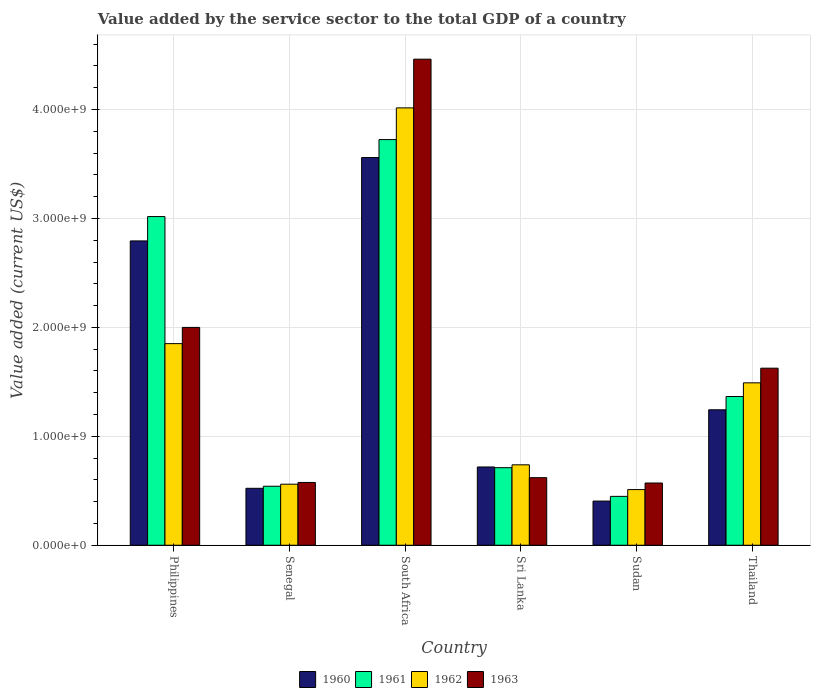Are the number of bars on each tick of the X-axis equal?
Offer a terse response. Yes. What is the label of the 3rd group of bars from the left?
Ensure brevity in your answer.  South Africa. What is the value added by the service sector to the total GDP in 1960 in Thailand?
Provide a succinct answer. 1.24e+09. Across all countries, what is the maximum value added by the service sector to the total GDP in 1962?
Provide a short and direct response. 4.01e+09. Across all countries, what is the minimum value added by the service sector to the total GDP in 1963?
Provide a short and direct response. 5.71e+08. In which country was the value added by the service sector to the total GDP in 1960 maximum?
Ensure brevity in your answer.  South Africa. In which country was the value added by the service sector to the total GDP in 1961 minimum?
Make the answer very short. Sudan. What is the total value added by the service sector to the total GDP in 1960 in the graph?
Ensure brevity in your answer.  9.24e+09. What is the difference between the value added by the service sector to the total GDP in 1960 in Senegal and that in Sri Lanka?
Your answer should be very brief. -1.96e+08. What is the difference between the value added by the service sector to the total GDP in 1961 in Sri Lanka and the value added by the service sector to the total GDP in 1963 in Thailand?
Your answer should be compact. -9.13e+08. What is the average value added by the service sector to the total GDP in 1961 per country?
Your answer should be compact. 1.63e+09. What is the difference between the value added by the service sector to the total GDP of/in 1963 and value added by the service sector to the total GDP of/in 1961 in Sri Lanka?
Offer a very short reply. -9.18e+07. In how many countries, is the value added by the service sector to the total GDP in 1961 greater than 4200000000 US$?
Give a very brief answer. 0. What is the ratio of the value added by the service sector to the total GDP in 1961 in Philippines to that in Sudan?
Your answer should be compact. 6.73. Is the value added by the service sector to the total GDP in 1963 in Senegal less than that in South Africa?
Ensure brevity in your answer.  Yes. What is the difference between the highest and the second highest value added by the service sector to the total GDP in 1961?
Provide a succinct answer. -7.07e+08. What is the difference between the highest and the lowest value added by the service sector to the total GDP in 1960?
Offer a very short reply. 3.15e+09. What does the 1st bar from the left in South Africa represents?
Ensure brevity in your answer.  1960. Is it the case that in every country, the sum of the value added by the service sector to the total GDP in 1961 and value added by the service sector to the total GDP in 1962 is greater than the value added by the service sector to the total GDP in 1960?
Provide a short and direct response. Yes. How many bars are there?
Offer a terse response. 24. How many countries are there in the graph?
Offer a terse response. 6. Are the values on the major ticks of Y-axis written in scientific E-notation?
Offer a terse response. Yes. Does the graph contain grids?
Make the answer very short. Yes. Where does the legend appear in the graph?
Offer a very short reply. Bottom center. What is the title of the graph?
Keep it short and to the point. Value added by the service sector to the total GDP of a country. Does "1977" appear as one of the legend labels in the graph?
Your answer should be very brief. No. What is the label or title of the Y-axis?
Provide a short and direct response. Value added (current US$). What is the Value added (current US$) of 1960 in Philippines?
Provide a succinct answer. 2.79e+09. What is the Value added (current US$) of 1961 in Philippines?
Provide a succinct answer. 3.02e+09. What is the Value added (current US$) in 1962 in Philippines?
Provide a succinct answer. 1.85e+09. What is the Value added (current US$) of 1963 in Philippines?
Provide a short and direct response. 2.00e+09. What is the Value added (current US$) of 1960 in Senegal?
Provide a succinct answer. 5.23e+08. What is the Value added (current US$) in 1961 in Senegal?
Your answer should be compact. 5.42e+08. What is the Value added (current US$) in 1962 in Senegal?
Offer a terse response. 5.60e+08. What is the Value added (current US$) of 1963 in Senegal?
Provide a succinct answer. 5.76e+08. What is the Value added (current US$) in 1960 in South Africa?
Offer a very short reply. 3.56e+09. What is the Value added (current US$) in 1961 in South Africa?
Your response must be concise. 3.72e+09. What is the Value added (current US$) in 1962 in South Africa?
Give a very brief answer. 4.01e+09. What is the Value added (current US$) of 1963 in South Africa?
Provide a succinct answer. 4.46e+09. What is the Value added (current US$) in 1960 in Sri Lanka?
Ensure brevity in your answer.  7.18e+08. What is the Value added (current US$) in 1961 in Sri Lanka?
Give a very brief answer. 7.12e+08. What is the Value added (current US$) in 1962 in Sri Lanka?
Ensure brevity in your answer.  7.38e+08. What is the Value added (current US$) of 1963 in Sri Lanka?
Provide a succinct answer. 6.20e+08. What is the Value added (current US$) of 1960 in Sudan?
Provide a short and direct response. 4.06e+08. What is the Value added (current US$) of 1961 in Sudan?
Make the answer very short. 4.49e+08. What is the Value added (current US$) of 1962 in Sudan?
Your answer should be compact. 5.11e+08. What is the Value added (current US$) in 1963 in Sudan?
Offer a terse response. 5.71e+08. What is the Value added (current US$) in 1960 in Thailand?
Your answer should be compact. 1.24e+09. What is the Value added (current US$) of 1961 in Thailand?
Offer a very short reply. 1.37e+09. What is the Value added (current US$) in 1962 in Thailand?
Keep it short and to the point. 1.49e+09. What is the Value added (current US$) in 1963 in Thailand?
Provide a short and direct response. 1.63e+09. Across all countries, what is the maximum Value added (current US$) of 1960?
Provide a succinct answer. 3.56e+09. Across all countries, what is the maximum Value added (current US$) of 1961?
Offer a terse response. 3.72e+09. Across all countries, what is the maximum Value added (current US$) of 1962?
Provide a short and direct response. 4.01e+09. Across all countries, what is the maximum Value added (current US$) of 1963?
Ensure brevity in your answer.  4.46e+09. Across all countries, what is the minimum Value added (current US$) of 1960?
Your response must be concise. 4.06e+08. Across all countries, what is the minimum Value added (current US$) of 1961?
Make the answer very short. 4.49e+08. Across all countries, what is the minimum Value added (current US$) in 1962?
Keep it short and to the point. 5.11e+08. Across all countries, what is the minimum Value added (current US$) in 1963?
Provide a succinct answer. 5.71e+08. What is the total Value added (current US$) in 1960 in the graph?
Your response must be concise. 9.24e+09. What is the total Value added (current US$) of 1961 in the graph?
Offer a very short reply. 9.81e+09. What is the total Value added (current US$) in 1962 in the graph?
Provide a succinct answer. 9.17e+09. What is the total Value added (current US$) in 1963 in the graph?
Your answer should be very brief. 9.85e+09. What is the difference between the Value added (current US$) in 1960 in Philippines and that in Senegal?
Give a very brief answer. 2.27e+09. What is the difference between the Value added (current US$) in 1961 in Philippines and that in Senegal?
Give a very brief answer. 2.48e+09. What is the difference between the Value added (current US$) of 1962 in Philippines and that in Senegal?
Your answer should be compact. 1.29e+09. What is the difference between the Value added (current US$) in 1963 in Philippines and that in Senegal?
Ensure brevity in your answer.  1.42e+09. What is the difference between the Value added (current US$) of 1960 in Philippines and that in South Africa?
Give a very brief answer. -7.66e+08. What is the difference between the Value added (current US$) of 1961 in Philippines and that in South Africa?
Give a very brief answer. -7.07e+08. What is the difference between the Value added (current US$) of 1962 in Philippines and that in South Africa?
Give a very brief answer. -2.16e+09. What is the difference between the Value added (current US$) of 1963 in Philippines and that in South Africa?
Your answer should be compact. -2.46e+09. What is the difference between the Value added (current US$) in 1960 in Philippines and that in Sri Lanka?
Your answer should be very brief. 2.08e+09. What is the difference between the Value added (current US$) of 1961 in Philippines and that in Sri Lanka?
Give a very brief answer. 2.31e+09. What is the difference between the Value added (current US$) of 1962 in Philippines and that in Sri Lanka?
Provide a succinct answer. 1.11e+09. What is the difference between the Value added (current US$) in 1963 in Philippines and that in Sri Lanka?
Keep it short and to the point. 1.38e+09. What is the difference between the Value added (current US$) of 1960 in Philippines and that in Sudan?
Keep it short and to the point. 2.39e+09. What is the difference between the Value added (current US$) in 1961 in Philippines and that in Sudan?
Your answer should be compact. 2.57e+09. What is the difference between the Value added (current US$) of 1962 in Philippines and that in Sudan?
Offer a terse response. 1.34e+09. What is the difference between the Value added (current US$) in 1963 in Philippines and that in Sudan?
Offer a very short reply. 1.43e+09. What is the difference between the Value added (current US$) in 1960 in Philippines and that in Thailand?
Make the answer very short. 1.55e+09. What is the difference between the Value added (current US$) of 1961 in Philippines and that in Thailand?
Provide a succinct answer. 1.65e+09. What is the difference between the Value added (current US$) of 1962 in Philippines and that in Thailand?
Your response must be concise. 3.60e+08. What is the difference between the Value added (current US$) of 1963 in Philippines and that in Thailand?
Your answer should be compact. 3.74e+08. What is the difference between the Value added (current US$) in 1960 in Senegal and that in South Africa?
Make the answer very short. -3.04e+09. What is the difference between the Value added (current US$) in 1961 in Senegal and that in South Africa?
Your response must be concise. -3.18e+09. What is the difference between the Value added (current US$) in 1962 in Senegal and that in South Africa?
Keep it short and to the point. -3.45e+09. What is the difference between the Value added (current US$) of 1963 in Senegal and that in South Africa?
Provide a short and direct response. -3.89e+09. What is the difference between the Value added (current US$) in 1960 in Senegal and that in Sri Lanka?
Provide a short and direct response. -1.96e+08. What is the difference between the Value added (current US$) in 1961 in Senegal and that in Sri Lanka?
Offer a terse response. -1.70e+08. What is the difference between the Value added (current US$) in 1962 in Senegal and that in Sri Lanka?
Offer a very short reply. -1.78e+08. What is the difference between the Value added (current US$) in 1963 in Senegal and that in Sri Lanka?
Provide a succinct answer. -4.38e+07. What is the difference between the Value added (current US$) of 1960 in Senegal and that in Sudan?
Offer a terse response. 1.17e+08. What is the difference between the Value added (current US$) of 1961 in Senegal and that in Sudan?
Provide a succinct answer. 9.30e+07. What is the difference between the Value added (current US$) in 1962 in Senegal and that in Sudan?
Give a very brief answer. 4.95e+07. What is the difference between the Value added (current US$) of 1963 in Senegal and that in Sudan?
Offer a terse response. 5.17e+06. What is the difference between the Value added (current US$) in 1960 in Senegal and that in Thailand?
Keep it short and to the point. -7.21e+08. What is the difference between the Value added (current US$) in 1961 in Senegal and that in Thailand?
Provide a short and direct response. -8.24e+08. What is the difference between the Value added (current US$) of 1962 in Senegal and that in Thailand?
Offer a terse response. -9.30e+08. What is the difference between the Value added (current US$) of 1963 in Senegal and that in Thailand?
Make the answer very short. -1.05e+09. What is the difference between the Value added (current US$) of 1960 in South Africa and that in Sri Lanka?
Provide a succinct answer. 2.84e+09. What is the difference between the Value added (current US$) in 1961 in South Africa and that in Sri Lanka?
Provide a short and direct response. 3.01e+09. What is the difference between the Value added (current US$) in 1962 in South Africa and that in Sri Lanka?
Offer a terse response. 3.28e+09. What is the difference between the Value added (current US$) of 1963 in South Africa and that in Sri Lanka?
Your answer should be very brief. 3.84e+09. What is the difference between the Value added (current US$) in 1960 in South Africa and that in Sudan?
Make the answer very short. 3.15e+09. What is the difference between the Value added (current US$) of 1961 in South Africa and that in Sudan?
Your answer should be very brief. 3.28e+09. What is the difference between the Value added (current US$) in 1962 in South Africa and that in Sudan?
Provide a succinct answer. 3.50e+09. What is the difference between the Value added (current US$) of 1963 in South Africa and that in Sudan?
Your response must be concise. 3.89e+09. What is the difference between the Value added (current US$) in 1960 in South Africa and that in Thailand?
Give a very brief answer. 2.32e+09. What is the difference between the Value added (current US$) in 1961 in South Africa and that in Thailand?
Give a very brief answer. 2.36e+09. What is the difference between the Value added (current US$) of 1962 in South Africa and that in Thailand?
Your answer should be very brief. 2.52e+09. What is the difference between the Value added (current US$) of 1963 in South Africa and that in Thailand?
Give a very brief answer. 2.84e+09. What is the difference between the Value added (current US$) in 1960 in Sri Lanka and that in Sudan?
Provide a short and direct response. 3.13e+08. What is the difference between the Value added (current US$) of 1961 in Sri Lanka and that in Sudan?
Make the answer very short. 2.63e+08. What is the difference between the Value added (current US$) in 1962 in Sri Lanka and that in Sudan?
Your answer should be compact. 2.27e+08. What is the difference between the Value added (current US$) in 1963 in Sri Lanka and that in Sudan?
Provide a succinct answer. 4.89e+07. What is the difference between the Value added (current US$) of 1960 in Sri Lanka and that in Thailand?
Keep it short and to the point. -5.25e+08. What is the difference between the Value added (current US$) in 1961 in Sri Lanka and that in Thailand?
Your answer should be compact. -6.53e+08. What is the difference between the Value added (current US$) in 1962 in Sri Lanka and that in Thailand?
Make the answer very short. -7.53e+08. What is the difference between the Value added (current US$) of 1963 in Sri Lanka and that in Thailand?
Offer a very short reply. -1.01e+09. What is the difference between the Value added (current US$) in 1960 in Sudan and that in Thailand?
Offer a terse response. -8.38e+08. What is the difference between the Value added (current US$) of 1961 in Sudan and that in Thailand?
Make the answer very short. -9.17e+08. What is the difference between the Value added (current US$) of 1962 in Sudan and that in Thailand?
Your response must be concise. -9.80e+08. What is the difference between the Value added (current US$) in 1963 in Sudan and that in Thailand?
Make the answer very short. -1.05e+09. What is the difference between the Value added (current US$) in 1960 in Philippines and the Value added (current US$) in 1961 in Senegal?
Offer a very short reply. 2.25e+09. What is the difference between the Value added (current US$) of 1960 in Philippines and the Value added (current US$) of 1962 in Senegal?
Make the answer very short. 2.23e+09. What is the difference between the Value added (current US$) in 1960 in Philippines and the Value added (current US$) in 1963 in Senegal?
Offer a terse response. 2.22e+09. What is the difference between the Value added (current US$) in 1961 in Philippines and the Value added (current US$) in 1962 in Senegal?
Ensure brevity in your answer.  2.46e+09. What is the difference between the Value added (current US$) in 1961 in Philippines and the Value added (current US$) in 1963 in Senegal?
Your response must be concise. 2.44e+09. What is the difference between the Value added (current US$) of 1962 in Philippines and the Value added (current US$) of 1963 in Senegal?
Provide a succinct answer. 1.27e+09. What is the difference between the Value added (current US$) in 1960 in Philippines and the Value added (current US$) in 1961 in South Africa?
Offer a terse response. -9.30e+08. What is the difference between the Value added (current US$) of 1960 in Philippines and the Value added (current US$) of 1962 in South Africa?
Give a very brief answer. -1.22e+09. What is the difference between the Value added (current US$) in 1960 in Philippines and the Value added (current US$) in 1963 in South Africa?
Your answer should be compact. -1.67e+09. What is the difference between the Value added (current US$) in 1961 in Philippines and the Value added (current US$) in 1962 in South Africa?
Your response must be concise. -9.98e+08. What is the difference between the Value added (current US$) of 1961 in Philippines and the Value added (current US$) of 1963 in South Africa?
Offer a very short reply. -1.44e+09. What is the difference between the Value added (current US$) of 1962 in Philippines and the Value added (current US$) of 1963 in South Africa?
Ensure brevity in your answer.  -2.61e+09. What is the difference between the Value added (current US$) in 1960 in Philippines and the Value added (current US$) in 1961 in Sri Lanka?
Keep it short and to the point. 2.08e+09. What is the difference between the Value added (current US$) in 1960 in Philippines and the Value added (current US$) in 1962 in Sri Lanka?
Your answer should be very brief. 2.06e+09. What is the difference between the Value added (current US$) in 1960 in Philippines and the Value added (current US$) in 1963 in Sri Lanka?
Your answer should be very brief. 2.17e+09. What is the difference between the Value added (current US$) of 1961 in Philippines and the Value added (current US$) of 1962 in Sri Lanka?
Offer a very short reply. 2.28e+09. What is the difference between the Value added (current US$) in 1961 in Philippines and the Value added (current US$) in 1963 in Sri Lanka?
Offer a very short reply. 2.40e+09. What is the difference between the Value added (current US$) of 1962 in Philippines and the Value added (current US$) of 1963 in Sri Lanka?
Your answer should be very brief. 1.23e+09. What is the difference between the Value added (current US$) of 1960 in Philippines and the Value added (current US$) of 1961 in Sudan?
Your answer should be compact. 2.35e+09. What is the difference between the Value added (current US$) of 1960 in Philippines and the Value added (current US$) of 1962 in Sudan?
Your answer should be very brief. 2.28e+09. What is the difference between the Value added (current US$) in 1960 in Philippines and the Value added (current US$) in 1963 in Sudan?
Your answer should be compact. 2.22e+09. What is the difference between the Value added (current US$) of 1961 in Philippines and the Value added (current US$) of 1962 in Sudan?
Your answer should be compact. 2.51e+09. What is the difference between the Value added (current US$) in 1961 in Philippines and the Value added (current US$) in 1963 in Sudan?
Provide a short and direct response. 2.45e+09. What is the difference between the Value added (current US$) in 1962 in Philippines and the Value added (current US$) in 1963 in Sudan?
Offer a terse response. 1.28e+09. What is the difference between the Value added (current US$) of 1960 in Philippines and the Value added (current US$) of 1961 in Thailand?
Give a very brief answer. 1.43e+09. What is the difference between the Value added (current US$) of 1960 in Philippines and the Value added (current US$) of 1962 in Thailand?
Provide a succinct answer. 1.30e+09. What is the difference between the Value added (current US$) of 1960 in Philippines and the Value added (current US$) of 1963 in Thailand?
Make the answer very short. 1.17e+09. What is the difference between the Value added (current US$) in 1961 in Philippines and the Value added (current US$) in 1962 in Thailand?
Offer a terse response. 1.53e+09. What is the difference between the Value added (current US$) of 1961 in Philippines and the Value added (current US$) of 1963 in Thailand?
Give a very brief answer. 1.39e+09. What is the difference between the Value added (current US$) of 1962 in Philippines and the Value added (current US$) of 1963 in Thailand?
Ensure brevity in your answer.  2.25e+08. What is the difference between the Value added (current US$) of 1960 in Senegal and the Value added (current US$) of 1961 in South Africa?
Offer a terse response. -3.20e+09. What is the difference between the Value added (current US$) in 1960 in Senegal and the Value added (current US$) in 1962 in South Africa?
Provide a succinct answer. -3.49e+09. What is the difference between the Value added (current US$) of 1960 in Senegal and the Value added (current US$) of 1963 in South Africa?
Your answer should be very brief. -3.94e+09. What is the difference between the Value added (current US$) of 1961 in Senegal and the Value added (current US$) of 1962 in South Africa?
Provide a short and direct response. -3.47e+09. What is the difference between the Value added (current US$) in 1961 in Senegal and the Value added (current US$) in 1963 in South Africa?
Ensure brevity in your answer.  -3.92e+09. What is the difference between the Value added (current US$) in 1962 in Senegal and the Value added (current US$) in 1963 in South Africa?
Your answer should be compact. -3.90e+09. What is the difference between the Value added (current US$) of 1960 in Senegal and the Value added (current US$) of 1961 in Sri Lanka?
Keep it short and to the point. -1.89e+08. What is the difference between the Value added (current US$) of 1960 in Senegal and the Value added (current US$) of 1962 in Sri Lanka?
Ensure brevity in your answer.  -2.16e+08. What is the difference between the Value added (current US$) of 1960 in Senegal and the Value added (current US$) of 1963 in Sri Lanka?
Offer a terse response. -9.75e+07. What is the difference between the Value added (current US$) of 1961 in Senegal and the Value added (current US$) of 1962 in Sri Lanka?
Offer a very short reply. -1.97e+08. What is the difference between the Value added (current US$) in 1961 in Senegal and the Value added (current US$) in 1963 in Sri Lanka?
Make the answer very short. -7.85e+07. What is the difference between the Value added (current US$) in 1962 in Senegal and the Value added (current US$) in 1963 in Sri Lanka?
Your response must be concise. -5.98e+07. What is the difference between the Value added (current US$) in 1960 in Senegal and the Value added (current US$) in 1961 in Sudan?
Your answer should be very brief. 7.40e+07. What is the difference between the Value added (current US$) in 1960 in Senegal and the Value added (current US$) in 1962 in Sudan?
Your response must be concise. 1.17e+07. What is the difference between the Value added (current US$) of 1960 in Senegal and the Value added (current US$) of 1963 in Sudan?
Ensure brevity in your answer.  -4.86e+07. What is the difference between the Value added (current US$) of 1961 in Senegal and the Value added (current US$) of 1962 in Sudan?
Ensure brevity in your answer.  3.07e+07. What is the difference between the Value added (current US$) in 1961 in Senegal and the Value added (current US$) in 1963 in Sudan?
Your answer should be compact. -2.96e+07. What is the difference between the Value added (current US$) of 1962 in Senegal and the Value added (current US$) of 1963 in Sudan?
Offer a terse response. -1.08e+07. What is the difference between the Value added (current US$) in 1960 in Senegal and the Value added (current US$) in 1961 in Thailand?
Provide a short and direct response. -8.43e+08. What is the difference between the Value added (current US$) of 1960 in Senegal and the Value added (current US$) of 1962 in Thailand?
Provide a short and direct response. -9.68e+08. What is the difference between the Value added (current US$) in 1960 in Senegal and the Value added (current US$) in 1963 in Thailand?
Offer a very short reply. -1.10e+09. What is the difference between the Value added (current US$) in 1961 in Senegal and the Value added (current US$) in 1962 in Thailand?
Make the answer very short. -9.49e+08. What is the difference between the Value added (current US$) of 1961 in Senegal and the Value added (current US$) of 1963 in Thailand?
Your response must be concise. -1.08e+09. What is the difference between the Value added (current US$) in 1962 in Senegal and the Value added (current US$) in 1963 in Thailand?
Keep it short and to the point. -1.06e+09. What is the difference between the Value added (current US$) in 1960 in South Africa and the Value added (current US$) in 1961 in Sri Lanka?
Your response must be concise. 2.85e+09. What is the difference between the Value added (current US$) of 1960 in South Africa and the Value added (current US$) of 1962 in Sri Lanka?
Provide a short and direct response. 2.82e+09. What is the difference between the Value added (current US$) of 1960 in South Africa and the Value added (current US$) of 1963 in Sri Lanka?
Make the answer very short. 2.94e+09. What is the difference between the Value added (current US$) in 1961 in South Africa and the Value added (current US$) in 1962 in Sri Lanka?
Your answer should be very brief. 2.99e+09. What is the difference between the Value added (current US$) in 1961 in South Africa and the Value added (current US$) in 1963 in Sri Lanka?
Your response must be concise. 3.10e+09. What is the difference between the Value added (current US$) of 1962 in South Africa and the Value added (current US$) of 1963 in Sri Lanka?
Ensure brevity in your answer.  3.39e+09. What is the difference between the Value added (current US$) in 1960 in South Africa and the Value added (current US$) in 1961 in Sudan?
Provide a short and direct response. 3.11e+09. What is the difference between the Value added (current US$) of 1960 in South Africa and the Value added (current US$) of 1962 in Sudan?
Keep it short and to the point. 3.05e+09. What is the difference between the Value added (current US$) of 1960 in South Africa and the Value added (current US$) of 1963 in Sudan?
Your answer should be very brief. 2.99e+09. What is the difference between the Value added (current US$) of 1961 in South Africa and the Value added (current US$) of 1962 in Sudan?
Make the answer very short. 3.21e+09. What is the difference between the Value added (current US$) of 1961 in South Africa and the Value added (current US$) of 1963 in Sudan?
Your answer should be very brief. 3.15e+09. What is the difference between the Value added (current US$) of 1962 in South Africa and the Value added (current US$) of 1963 in Sudan?
Your answer should be compact. 3.44e+09. What is the difference between the Value added (current US$) in 1960 in South Africa and the Value added (current US$) in 1961 in Thailand?
Provide a short and direct response. 2.19e+09. What is the difference between the Value added (current US$) in 1960 in South Africa and the Value added (current US$) in 1962 in Thailand?
Provide a short and direct response. 2.07e+09. What is the difference between the Value added (current US$) of 1960 in South Africa and the Value added (current US$) of 1963 in Thailand?
Provide a short and direct response. 1.93e+09. What is the difference between the Value added (current US$) in 1961 in South Africa and the Value added (current US$) in 1962 in Thailand?
Your response must be concise. 2.23e+09. What is the difference between the Value added (current US$) in 1961 in South Africa and the Value added (current US$) in 1963 in Thailand?
Offer a very short reply. 2.10e+09. What is the difference between the Value added (current US$) in 1962 in South Africa and the Value added (current US$) in 1963 in Thailand?
Ensure brevity in your answer.  2.39e+09. What is the difference between the Value added (current US$) of 1960 in Sri Lanka and the Value added (current US$) of 1961 in Sudan?
Ensure brevity in your answer.  2.70e+08. What is the difference between the Value added (current US$) in 1960 in Sri Lanka and the Value added (current US$) in 1962 in Sudan?
Make the answer very short. 2.08e+08. What is the difference between the Value added (current US$) of 1960 in Sri Lanka and the Value added (current US$) of 1963 in Sudan?
Make the answer very short. 1.47e+08. What is the difference between the Value added (current US$) in 1961 in Sri Lanka and the Value added (current US$) in 1962 in Sudan?
Provide a succinct answer. 2.01e+08. What is the difference between the Value added (current US$) of 1961 in Sri Lanka and the Value added (current US$) of 1963 in Sudan?
Your answer should be compact. 1.41e+08. What is the difference between the Value added (current US$) of 1962 in Sri Lanka and the Value added (current US$) of 1963 in Sudan?
Provide a succinct answer. 1.67e+08. What is the difference between the Value added (current US$) of 1960 in Sri Lanka and the Value added (current US$) of 1961 in Thailand?
Give a very brief answer. -6.47e+08. What is the difference between the Value added (current US$) of 1960 in Sri Lanka and the Value added (current US$) of 1962 in Thailand?
Ensure brevity in your answer.  -7.72e+08. What is the difference between the Value added (current US$) in 1960 in Sri Lanka and the Value added (current US$) in 1963 in Thailand?
Make the answer very short. -9.07e+08. What is the difference between the Value added (current US$) in 1961 in Sri Lanka and the Value added (current US$) in 1962 in Thailand?
Ensure brevity in your answer.  -7.79e+08. What is the difference between the Value added (current US$) of 1961 in Sri Lanka and the Value added (current US$) of 1963 in Thailand?
Your response must be concise. -9.13e+08. What is the difference between the Value added (current US$) in 1962 in Sri Lanka and the Value added (current US$) in 1963 in Thailand?
Offer a very short reply. -8.87e+08. What is the difference between the Value added (current US$) of 1960 in Sudan and the Value added (current US$) of 1961 in Thailand?
Make the answer very short. -9.60e+08. What is the difference between the Value added (current US$) of 1960 in Sudan and the Value added (current US$) of 1962 in Thailand?
Offer a very short reply. -1.09e+09. What is the difference between the Value added (current US$) in 1960 in Sudan and the Value added (current US$) in 1963 in Thailand?
Offer a very short reply. -1.22e+09. What is the difference between the Value added (current US$) in 1961 in Sudan and the Value added (current US$) in 1962 in Thailand?
Make the answer very short. -1.04e+09. What is the difference between the Value added (current US$) of 1961 in Sudan and the Value added (current US$) of 1963 in Thailand?
Provide a short and direct response. -1.18e+09. What is the difference between the Value added (current US$) in 1962 in Sudan and the Value added (current US$) in 1963 in Thailand?
Your answer should be very brief. -1.11e+09. What is the average Value added (current US$) of 1960 per country?
Ensure brevity in your answer.  1.54e+09. What is the average Value added (current US$) in 1961 per country?
Your response must be concise. 1.63e+09. What is the average Value added (current US$) of 1962 per country?
Provide a succinct answer. 1.53e+09. What is the average Value added (current US$) in 1963 per country?
Offer a terse response. 1.64e+09. What is the difference between the Value added (current US$) of 1960 and Value added (current US$) of 1961 in Philippines?
Your answer should be very brief. -2.24e+08. What is the difference between the Value added (current US$) in 1960 and Value added (current US$) in 1962 in Philippines?
Keep it short and to the point. 9.43e+08. What is the difference between the Value added (current US$) in 1960 and Value added (current US$) in 1963 in Philippines?
Provide a succinct answer. 7.94e+08. What is the difference between the Value added (current US$) of 1961 and Value added (current US$) of 1962 in Philippines?
Your response must be concise. 1.17e+09. What is the difference between the Value added (current US$) in 1961 and Value added (current US$) in 1963 in Philippines?
Ensure brevity in your answer.  1.02e+09. What is the difference between the Value added (current US$) in 1962 and Value added (current US$) in 1963 in Philippines?
Make the answer very short. -1.49e+08. What is the difference between the Value added (current US$) of 1960 and Value added (current US$) of 1961 in Senegal?
Provide a succinct answer. -1.90e+07. What is the difference between the Value added (current US$) of 1960 and Value added (current US$) of 1962 in Senegal?
Provide a succinct answer. -3.77e+07. What is the difference between the Value added (current US$) in 1960 and Value added (current US$) in 1963 in Senegal?
Your answer should be compact. -5.38e+07. What is the difference between the Value added (current US$) in 1961 and Value added (current US$) in 1962 in Senegal?
Offer a very short reply. -1.87e+07. What is the difference between the Value added (current US$) in 1961 and Value added (current US$) in 1963 in Senegal?
Offer a very short reply. -3.48e+07. What is the difference between the Value added (current US$) of 1962 and Value added (current US$) of 1963 in Senegal?
Provide a succinct answer. -1.60e+07. What is the difference between the Value added (current US$) of 1960 and Value added (current US$) of 1961 in South Africa?
Give a very brief answer. -1.65e+08. What is the difference between the Value added (current US$) in 1960 and Value added (current US$) in 1962 in South Africa?
Your answer should be compact. -4.56e+08. What is the difference between the Value added (current US$) in 1960 and Value added (current US$) in 1963 in South Africa?
Offer a very short reply. -9.03e+08. What is the difference between the Value added (current US$) of 1961 and Value added (current US$) of 1962 in South Africa?
Your response must be concise. -2.91e+08. What is the difference between the Value added (current US$) of 1961 and Value added (current US$) of 1963 in South Africa?
Give a very brief answer. -7.38e+08. What is the difference between the Value added (current US$) of 1962 and Value added (current US$) of 1963 in South Africa?
Offer a terse response. -4.47e+08. What is the difference between the Value added (current US$) of 1960 and Value added (current US$) of 1961 in Sri Lanka?
Keep it short and to the point. 6.51e+06. What is the difference between the Value added (current US$) of 1960 and Value added (current US$) of 1962 in Sri Lanka?
Give a very brief answer. -1.98e+07. What is the difference between the Value added (current US$) of 1960 and Value added (current US$) of 1963 in Sri Lanka?
Your answer should be very brief. 9.83e+07. What is the difference between the Value added (current US$) in 1961 and Value added (current US$) in 1962 in Sri Lanka?
Provide a succinct answer. -2.63e+07. What is the difference between the Value added (current US$) in 1961 and Value added (current US$) in 1963 in Sri Lanka?
Provide a short and direct response. 9.18e+07. What is the difference between the Value added (current US$) in 1962 and Value added (current US$) in 1963 in Sri Lanka?
Offer a terse response. 1.18e+08. What is the difference between the Value added (current US$) of 1960 and Value added (current US$) of 1961 in Sudan?
Offer a very short reply. -4.31e+07. What is the difference between the Value added (current US$) in 1960 and Value added (current US$) in 1962 in Sudan?
Give a very brief answer. -1.05e+08. What is the difference between the Value added (current US$) in 1960 and Value added (current US$) in 1963 in Sudan?
Offer a very short reply. -1.66e+08. What is the difference between the Value added (current US$) of 1961 and Value added (current US$) of 1962 in Sudan?
Offer a terse response. -6.23e+07. What is the difference between the Value added (current US$) of 1961 and Value added (current US$) of 1963 in Sudan?
Offer a very short reply. -1.23e+08. What is the difference between the Value added (current US$) of 1962 and Value added (current US$) of 1963 in Sudan?
Give a very brief answer. -6.03e+07. What is the difference between the Value added (current US$) in 1960 and Value added (current US$) in 1961 in Thailand?
Ensure brevity in your answer.  -1.22e+08. What is the difference between the Value added (current US$) in 1960 and Value added (current US$) in 1962 in Thailand?
Offer a very short reply. -2.47e+08. What is the difference between the Value added (current US$) of 1960 and Value added (current US$) of 1963 in Thailand?
Your answer should be very brief. -3.82e+08. What is the difference between the Value added (current US$) in 1961 and Value added (current US$) in 1962 in Thailand?
Ensure brevity in your answer.  -1.26e+08. What is the difference between the Value added (current US$) in 1961 and Value added (current US$) in 1963 in Thailand?
Your answer should be compact. -2.60e+08. What is the difference between the Value added (current US$) of 1962 and Value added (current US$) of 1963 in Thailand?
Make the answer very short. -1.35e+08. What is the ratio of the Value added (current US$) in 1960 in Philippines to that in Senegal?
Provide a succinct answer. 5.35. What is the ratio of the Value added (current US$) in 1961 in Philippines to that in Senegal?
Provide a succinct answer. 5.57. What is the ratio of the Value added (current US$) in 1962 in Philippines to that in Senegal?
Offer a terse response. 3.3. What is the ratio of the Value added (current US$) in 1963 in Philippines to that in Senegal?
Offer a very short reply. 3.47. What is the ratio of the Value added (current US$) in 1960 in Philippines to that in South Africa?
Make the answer very short. 0.78. What is the ratio of the Value added (current US$) in 1961 in Philippines to that in South Africa?
Provide a short and direct response. 0.81. What is the ratio of the Value added (current US$) in 1962 in Philippines to that in South Africa?
Your answer should be very brief. 0.46. What is the ratio of the Value added (current US$) in 1963 in Philippines to that in South Africa?
Provide a succinct answer. 0.45. What is the ratio of the Value added (current US$) of 1960 in Philippines to that in Sri Lanka?
Offer a terse response. 3.89. What is the ratio of the Value added (current US$) in 1961 in Philippines to that in Sri Lanka?
Your answer should be very brief. 4.24. What is the ratio of the Value added (current US$) in 1962 in Philippines to that in Sri Lanka?
Ensure brevity in your answer.  2.51. What is the ratio of the Value added (current US$) of 1963 in Philippines to that in Sri Lanka?
Make the answer very short. 3.22. What is the ratio of the Value added (current US$) in 1960 in Philippines to that in Sudan?
Provide a succinct answer. 6.89. What is the ratio of the Value added (current US$) in 1961 in Philippines to that in Sudan?
Offer a terse response. 6.73. What is the ratio of the Value added (current US$) in 1962 in Philippines to that in Sudan?
Your answer should be very brief. 3.62. What is the ratio of the Value added (current US$) in 1963 in Philippines to that in Sudan?
Provide a short and direct response. 3.5. What is the ratio of the Value added (current US$) of 1960 in Philippines to that in Thailand?
Your answer should be very brief. 2.25. What is the ratio of the Value added (current US$) of 1961 in Philippines to that in Thailand?
Make the answer very short. 2.21. What is the ratio of the Value added (current US$) in 1962 in Philippines to that in Thailand?
Provide a succinct answer. 1.24. What is the ratio of the Value added (current US$) in 1963 in Philippines to that in Thailand?
Keep it short and to the point. 1.23. What is the ratio of the Value added (current US$) of 1960 in Senegal to that in South Africa?
Provide a short and direct response. 0.15. What is the ratio of the Value added (current US$) of 1961 in Senegal to that in South Africa?
Provide a short and direct response. 0.15. What is the ratio of the Value added (current US$) of 1962 in Senegal to that in South Africa?
Keep it short and to the point. 0.14. What is the ratio of the Value added (current US$) in 1963 in Senegal to that in South Africa?
Your answer should be very brief. 0.13. What is the ratio of the Value added (current US$) of 1960 in Senegal to that in Sri Lanka?
Give a very brief answer. 0.73. What is the ratio of the Value added (current US$) in 1961 in Senegal to that in Sri Lanka?
Keep it short and to the point. 0.76. What is the ratio of the Value added (current US$) of 1962 in Senegal to that in Sri Lanka?
Provide a short and direct response. 0.76. What is the ratio of the Value added (current US$) of 1963 in Senegal to that in Sri Lanka?
Your answer should be very brief. 0.93. What is the ratio of the Value added (current US$) in 1960 in Senegal to that in Sudan?
Offer a very short reply. 1.29. What is the ratio of the Value added (current US$) in 1961 in Senegal to that in Sudan?
Offer a very short reply. 1.21. What is the ratio of the Value added (current US$) in 1962 in Senegal to that in Sudan?
Your answer should be compact. 1.1. What is the ratio of the Value added (current US$) of 1963 in Senegal to that in Sudan?
Make the answer very short. 1.01. What is the ratio of the Value added (current US$) of 1960 in Senegal to that in Thailand?
Make the answer very short. 0.42. What is the ratio of the Value added (current US$) in 1961 in Senegal to that in Thailand?
Offer a terse response. 0.4. What is the ratio of the Value added (current US$) in 1962 in Senegal to that in Thailand?
Provide a succinct answer. 0.38. What is the ratio of the Value added (current US$) of 1963 in Senegal to that in Thailand?
Give a very brief answer. 0.35. What is the ratio of the Value added (current US$) in 1960 in South Africa to that in Sri Lanka?
Your answer should be compact. 4.95. What is the ratio of the Value added (current US$) of 1961 in South Africa to that in Sri Lanka?
Offer a terse response. 5.23. What is the ratio of the Value added (current US$) of 1962 in South Africa to that in Sri Lanka?
Give a very brief answer. 5.44. What is the ratio of the Value added (current US$) of 1963 in South Africa to that in Sri Lanka?
Your answer should be compact. 7.19. What is the ratio of the Value added (current US$) in 1960 in South Africa to that in Sudan?
Provide a short and direct response. 8.78. What is the ratio of the Value added (current US$) in 1961 in South Africa to that in Sudan?
Keep it short and to the point. 8.3. What is the ratio of the Value added (current US$) of 1962 in South Africa to that in Sudan?
Provide a succinct answer. 7.86. What is the ratio of the Value added (current US$) of 1963 in South Africa to that in Sudan?
Your response must be concise. 7.81. What is the ratio of the Value added (current US$) in 1960 in South Africa to that in Thailand?
Your answer should be compact. 2.86. What is the ratio of the Value added (current US$) in 1961 in South Africa to that in Thailand?
Keep it short and to the point. 2.73. What is the ratio of the Value added (current US$) in 1962 in South Africa to that in Thailand?
Give a very brief answer. 2.69. What is the ratio of the Value added (current US$) of 1963 in South Africa to that in Thailand?
Ensure brevity in your answer.  2.75. What is the ratio of the Value added (current US$) in 1960 in Sri Lanka to that in Sudan?
Your answer should be very brief. 1.77. What is the ratio of the Value added (current US$) in 1961 in Sri Lanka to that in Sudan?
Offer a very short reply. 1.59. What is the ratio of the Value added (current US$) in 1962 in Sri Lanka to that in Sudan?
Your answer should be very brief. 1.45. What is the ratio of the Value added (current US$) in 1963 in Sri Lanka to that in Sudan?
Your answer should be compact. 1.09. What is the ratio of the Value added (current US$) of 1960 in Sri Lanka to that in Thailand?
Your response must be concise. 0.58. What is the ratio of the Value added (current US$) of 1961 in Sri Lanka to that in Thailand?
Offer a terse response. 0.52. What is the ratio of the Value added (current US$) in 1962 in Sri Lanka to that in Thailand?
Offer a very short reply. 0.5. What is the ratio of the Value added (current US$) in 1963 in Sri Lanka to that in Thailand?
Ensure brevity in your answer.  0.38. What is the ratio of the Value added (current US$) of 1960 in Sudan to that in Thailand?
Your response must be concise. 0.33. What is the ratio of the Value added (current US$) of 1961 in Sudan to that in Thailand?
Give a very brief answer. 0.33. What is the ratio of the Value added (current US$) in 1962 in Sudan to that in Thailand?
Keep it short and to the point. 0.34. What is the ratio of the Value added (current US$) of 1963 in Sudan to that in Thailand?
Offer a terse response. 0.35. What is the difference between the highest and the second highest Value added (current US$) of 1960?
Provide a succinct answer. 7.66e+08. What is the difference between the highest and the second highest Value added (current US$) in 1961?
Offer a very short reply. 7.07e+08. What is the difference between the highest and the second highest Value added (current US$) of 1962?
Give a very brief answer. 2.16e+09. What is the difference between the highest and the second highest Value added (current US$) of 1963?
Provide a succinct answer. 2.46e+09. What is the difference between the highest and the lowest Value added (current US$) of 1960?
Provide a succinct answer. 3.15e+09. What is the difference between the highest and the lowest Value added (current US$) in 1961?
Offer a very short reply. 3.28e+09. What is the difference between the highest and the lowest Value added (current US$) of 1962?
Your answer should be compact. 3.50e+09. What is the difference between the highest and the lowest Value added (current US$) in 1963?
Your response must be concise. 3.89e+09. 